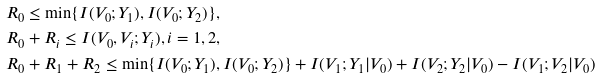Convert formula to latex. <formula><loc_0><loc_0><loc_500><loc_500>& R _ { 0 } \leq \min \{ I ( V _ { 0 } ; Y _ { 1 } ) , I ( V _ { 0 } ; Y _ { 2 } ) \} , \\ & R _ { 0 } + R _ { i } \leq I ( V _ { 0 } , V _ { i } ; Y _ { i } ) , i = 1 , 2 , \\ & R _ { 0 } + R _ { 1 } + R _ { 2 } \leq \min \{ I ( V _ { 0 } ; Y _ { 1 } ) , I ( V _ { 0 } ; Y _ { 2 } ) \} + I ( V _ { 1 } ; Y _ { 1 } | V _ { 0 } ) + I ( V _ { 2 } ; Y _ { 2 } | V _ { 0 } ) - I ( V _ { 1 } ; V _ { 2 } | V _ { 0 } )</formula> 